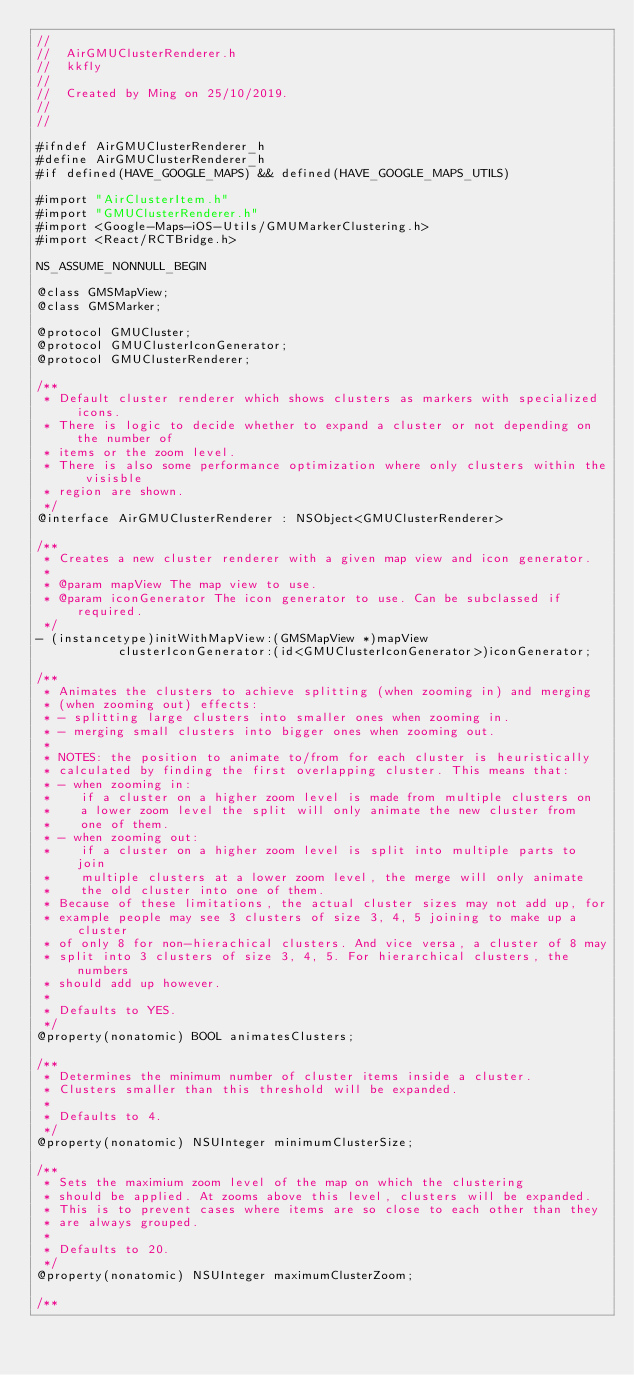<code> <loc_0><loc_0><loc_500><loc_500><_C_>//
//  AirGMUClusterRenderer.h
//  kkfly
//
//  Created by Ming on 25/10/2019.
// 
//

#ifndef AirGMUClusterRenderer_h
#define AirGMUClusterRenderer_h
#if defined(HAVE_GOOGLE_MAPS) && defined(HAVE_GOOGLE_MAPS_UTILS)

#import "AirClusterItem.h"
#import "GMUClusterRenderer.h"
#import <Google-Maps-iOS-Utils/GMUMarkerClustering.h>
#import <React/RCTBridge.h>

NS_ASSUME_NONNULL_BEGIN

@class GMSMapView;
@class GMSMarker;

@protocol GMUCluster;
@protocol GMUClusterIconGenerator;
@protocol GMUClusterRenderer;

/**
 * Default cluster renderer which shows clusters as markers with specialized icons.
 * There is logic to decide whether to expand a cluster or not depending on the number of
 * items or the zoom level.
 * There is also some performance optimization where only clusters within the visisble
 * region are shown.
 */
@interface AirGMUClusterRenderer : NSObject<GMUClusterRenderer>

/**
 * Creates a new cluster renderer with a given map view and icon generator.
 *
 * @param mapView The map view to use.
 * @param iconGenerator The icon generator to use. Can be subclassed if required.
 */
- (instancetype)initWithMapView:(GMSMapView *)mapView
           clusterIconGenerator:(id<GMUClusterIconGenerator>)iconGenerator;

/**
 * Animates the clusters to achieve splitting (when zooming in) and merging
 * (when zooming out) effects:
 * - splitting large clusters into smaller ones when zooming in.
 * - merging small clusters into bigger ones when zooming out.
 *
 * NOTES: the position to animate to/from for each cluster is heuristically
 * calculated by finding the first overlapping cluster. This means that:
 * - when zooming in:
 *    if a cluster on a higher zoom level is made from multiple clusters on
 *    a lower zoom level the split will only animate the new cluster from
 *    one of them.
 * - when zooming out:
 *    if a cluster on a higher zoom level is split into multiple parts to join
 *    multiple clusters at a lower zoom level, the merge will only animate
 *    the old cluster into one of them.
 * Because of these limitations, the actual cluster sizes may not add up, for
 * example people may see 3 clusters of size 3, 4, 5 joining to make up a cluster
 * of only 8 for non-hierachical clusters. And vice versa, a cluster of 8 may
 * split into 3 clusters of size 3, 4, 5. For hierarchical clusters, the numbers
 * should add up however.
 *
 * Defaults to YES.
 */
@property(nonatomic) BOOL animatesClusters;

/**
 * Determines the minimum number of cluster items inside a cluster.
 * Clusters smaller than this threshold will be expanded.
 *
 * Defaults to 4.
 */
@property(nonatomic) NSUInteger minimumClusterSize;

/**
 * Sets the maximium zoom level of the map on which the clustering
 * should be applied. At zooms above this level, clusters will be expanded.
 * This is to prevent cases where items are so close to each other than they
 * are always grouped.
 *
 * Defaults to 20.
 */
@property(nonatomic) NSUInteger maximumClusterZoom;

/**</code> 